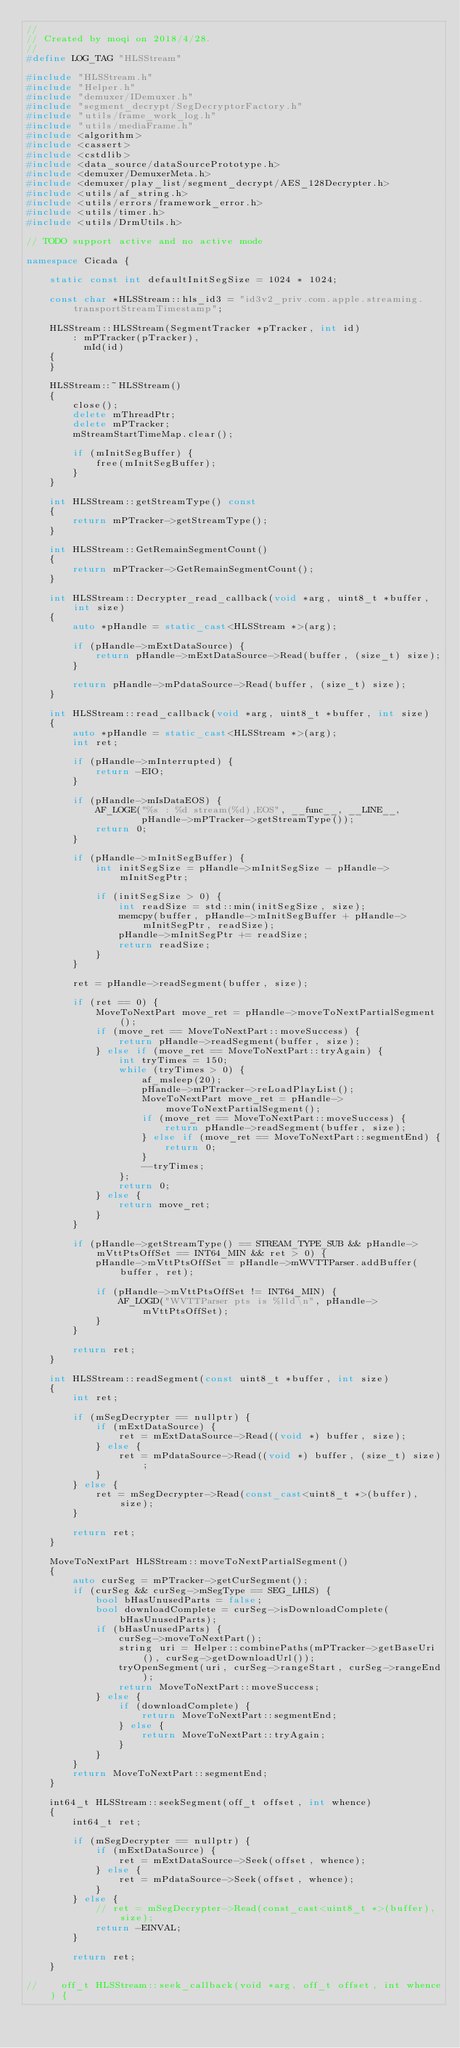<code> <loc_0><loc_0><loc_500><loc_500><_C++_>//
// Created by moqi on 2018/4/28.
//
#define LOG_TAG "HLSStream"

#include "HLSStream.h"
#include "Helper.h"
#include "demuxer/IDemuxer.h"
#include "segment_decrypt/SegDecryptorFactory.h"
#include "utils/frame_work_log.h"
#include "utils/mediaFrame.h"
#include <algorithm>
#include <cassert>
#include <cstdlib>
#include <data_source/dataSourcePrototype.h>
#include <demuxer/DemuxerMeta.h>
#include <demuxer/play_list/segment_decrypt/AES_128Decrypter.h>
#include <utils/af_string.h>
#include <utils/errors/framework_error.h>
#include <utils/timer.h>
#include <utils/DrmUtils.h>

// TODO support active and no active mode

namespace Cicada {

    static const int defaultInitSegSize = 1024 * 1024;

    const char *HLSStream::hls_id3 = "id3v2_priv.com.apple.streaming.transportStreamTimestamp";

    HLSStream::HLSStream(SegmentTracker *pTracker, int id)
        : mPTracker(pTracker),
          mId(id)
    {
    }

    HLSStream::~HLSStream()
    {
        close();
        delete mThreadPtr;
        delete mPTracker;
        mStreamStartTimeMap.clear();

        if (mInitSegBuffer) {
            free(mInitSegBuffer);
        }
    }

    int HLSStream::getStreamType() const
    {
        return mPTracker->getStreamType();
    }

    int HLSStream::GetRemainSegmentCount()
    {
        return mPTracker->GetRemainSegmentCount();
    }

    int HLSStream::Decrypter_read_callback(void *arg, uint8_t *buffer, int size)
    {
        auto *pHandle = static_cast<HLSStream *>(arg);

        if (pHandle->mExtDataSource) {
            return pHandle->mExtDataSource->Read(buffer, (size_t) size);
        }

        return pHandle->mPdataSource->Read(buffer, (size_t) size);
    }

    int HLSStream::read_callback(void *arg, uint8_t *buffer, int size)
    {
        auto *pHandle = static_cast<HLSStream *>(arg);
        int ret;

        if (pHandle->mInterrupted) {
            return -EIO;
        }

        if (pHandle->mIsDataEOS) {
            AF_LOGE("%s : %d stream(%d),EOS", __func__, __LINE__,
                    pHandle->mPTracker->getStreamType());
            return 0;
        }

        if (pHandle->mInitSegBuffer) {
            int initSegSize = pHandle->mInitSegSize - pHandle->mInitSegPtr;

            if (initSegSize > 0) {
                int readSize = std::min(initSegSize, size);
                memcpy(buffer, pHandle->mInitSegBuffer + pHandle->mInitSegPtr, readSize);
                pHandle->mInitSegPtr += readSize;
                return readSize;
            }
        }

        ret = pHandle->readSegment(buffer, size);

        if (ret == 0) {
            MoveToNextPart move_ret = pHandle->moveToNextPartialSegment();
            if (move_ret == MoveToNextPart::moveSuccess) {
                return pHandle->readSegment(buffer, size);
            } else if (move_ret == MoveToNextPart::tryAgain) {
                int tryTimes = 150;
                while (tryTimes > 0) {
                    af_msleep(20);
                    pHandle->mPTracker->reLoadPlayList();
                    MoveToNextPart move_ret = pHandle->moveToNextPartialSegment();
                    if (move_ret == MoveToNextPart::moveSuccess) {
                        return pHandle->readSegment(buffer, size);
                    } else if (move_ret == MoveToNextPart::segmentEnd) {
                        return 0;
                    }
                    --tryTimes;
                };
                return 0;
            } else {
                return move_ret;
            }
        }

        if (pHandle->getStreamType() == STREAM_TYPE_SUB && pHandle->mVttPtsOffSet == INT64_MIN && ret > 0) {
            pHandle->mVttPtsOffSet = pHandle->mWVTTParser.addBuffer(buffer, ret);

            if (pHandle->mVttPtsOffSet != INT64_MIN) {
                AF_LOGD("WVTTParser pts is %lld\n", pHandle->mVttPtsOffSet);
            }
        }

        return ret;
    }

    int HLSStream::readSegment(const uint8_t *buffer, int size)
    {
        int ret;

        if (mSegDecrypter == nullptr) {
            if (mExtDataSource) {
                ret = mExtDataSource->Read((void *) buffer, size);
            } else {
                ret = mPdataSource->Read((void *) buffer, (size_t) size);
            }
        } else {
            ret = mSegDecrypter->Read(const_cast<uint8_t *>(buffer), size);
        }

        return ret;
    }

    MoveToNextPart HLSStream::moveToNextPartialSegment()
    {
        auto curSeg = mPTracker->getCurSegment();
        if (curSeg && curSeg->mSegType == SEG_LHLS) {
            bool bHasUnusedParts = false;
            bool downloadComplete = curSeg->isDownloadComplete(bHasUnusedParts);
            if (bHasUnusedParts) {
                curSeg->moveToNextPart();
                string uri = Helper::combinePaths(mPTracker->getBaseUri(), curSeg->getDownloadUrl());
                tryOpenSegment(uri, curSeg->rangeStart, curSeg->rangeEnd);
                return MoveToNextPart::moveSuccess;
            } else {
                if (downloadComplete) {
                    return MoveToNextPart::segmentEnd;
                } else {
                    return MoveToNextPart::tryAgain;
                }
            }
        }
        return MoveToNextPart::segmentEnd;
    }

    int64_t HLSStream::seekSegment(off_t offset, int whence)
    {
        int64_t ret;

        if (mSegDecrypter == nullptr) {
            if (mExtDataSource) {
                ret = mExtDataSource->Seek(offset, whence);
            } else {
                ret = mPdataSource->Seek(offset, whence);
            }
        } else {
            // ret = mSegDecrypter->Read(const_cast<uint8_t *>(buffer), size);
            return -EINVAL;
        }

        return ret;
    }

//    off_t HLSStream::seek_callback(void *arg, off_t offset, int whence) {</code> 